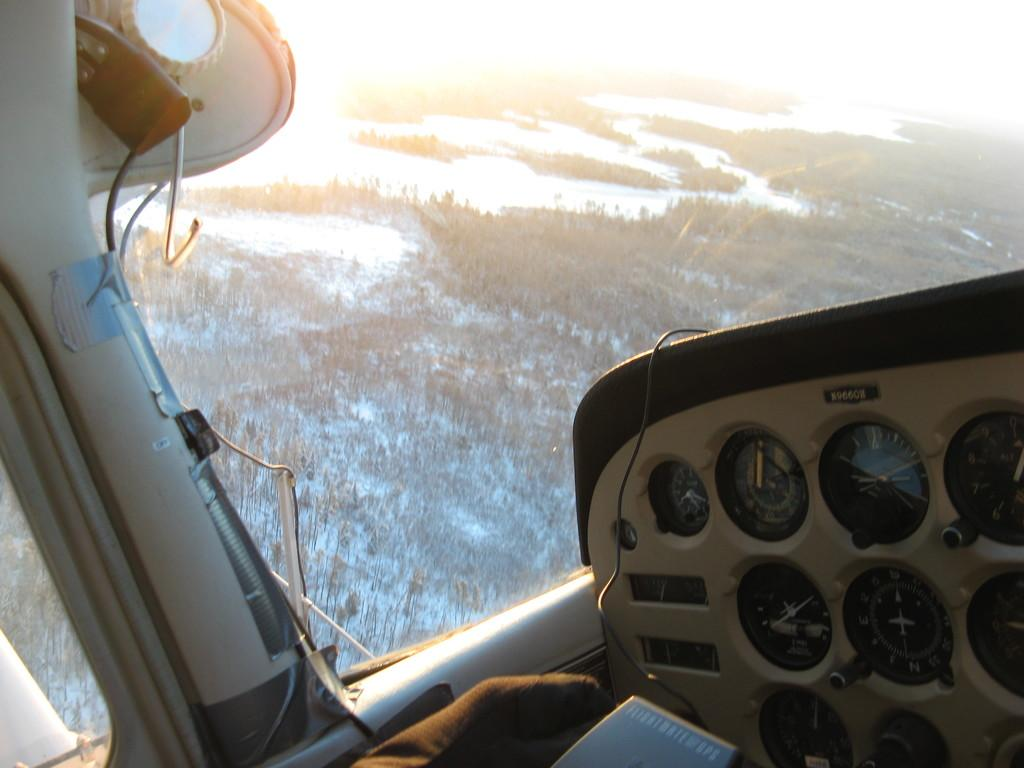What is the main subject of the image? The image shows the cockpit of a plane. What type of instruments are present in the cockpit? There are speedometers in the cockpit. What is the material of the window in the cockpit? There is a glass window in the cockpit. What can be seen through the glass window in the image? Trees and water are visible through the glass window. What color is the orange peel in the image? There is no orange or orange peel present in the image. Can you describe the skin of the person in the cockpit? There is no person visible in the image, and therefore no skin can be described. 